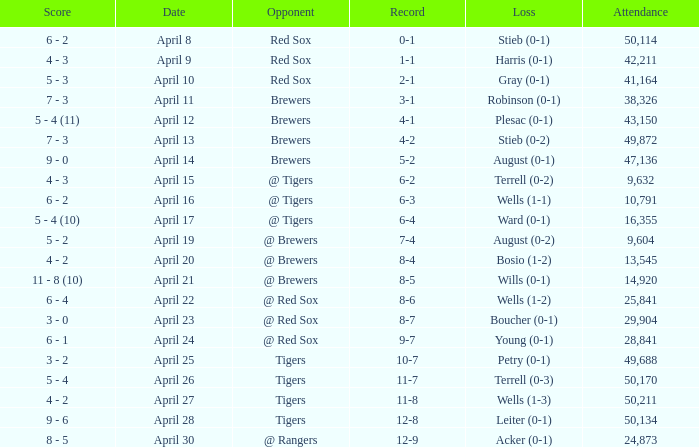Which opponent has an attendance greater than 29,904 and 11-8 as the record? Tigers. 